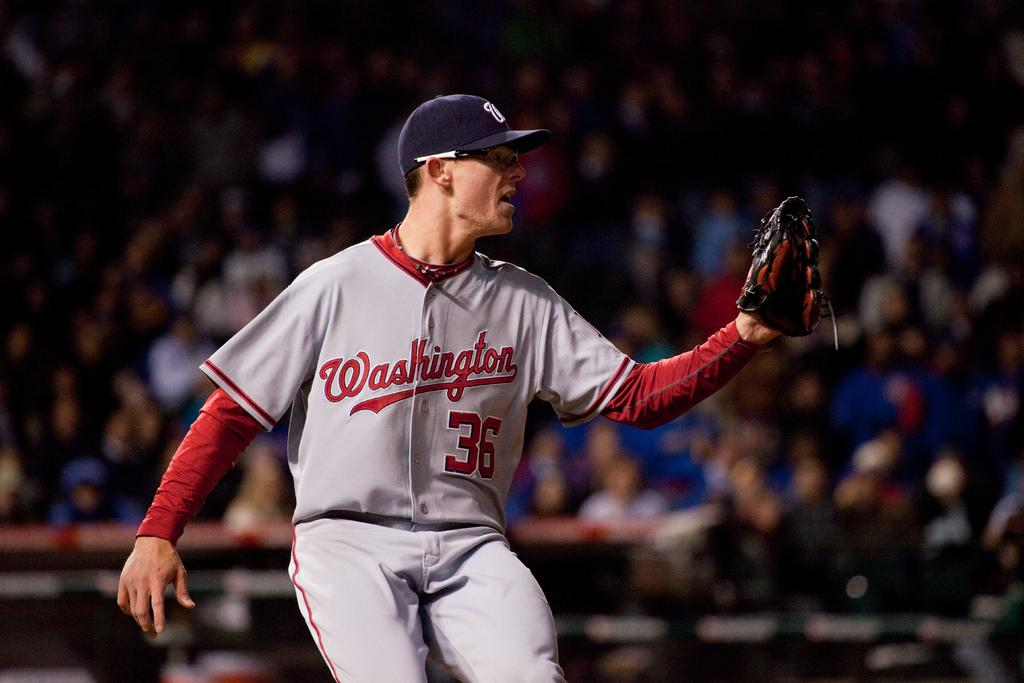<image>
Give a short and clear explanation of the subsequent image. Washington Nationals player number 36 has a glove on his left hand. 